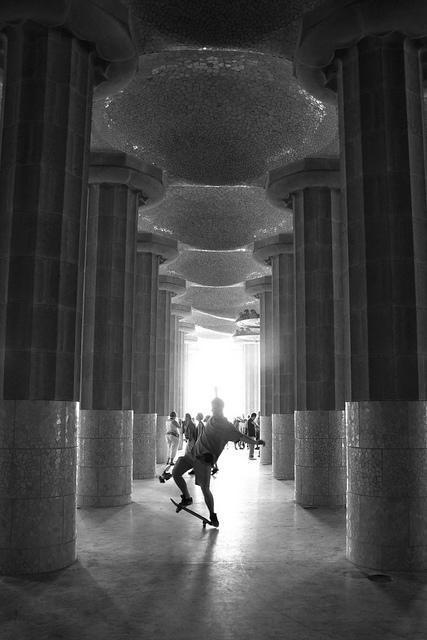How many rolls of toilet paper do you see?
Give a very brief answer. 0. 